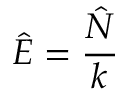<formula> <loc_0><loc_0><loc_500><loc_500>\hat { E } = \frac { \hat { N } } { k }</formula> 